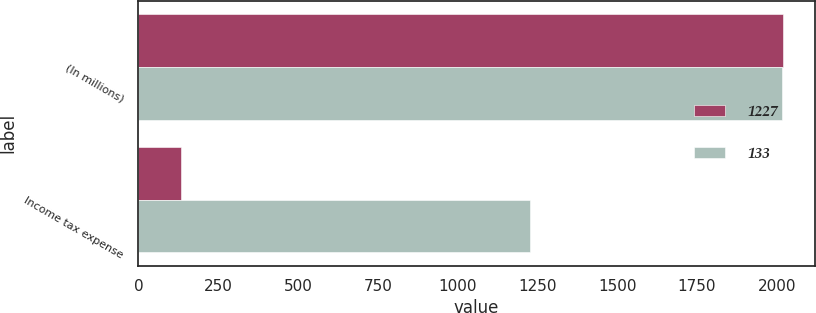Convert chart to OTSL. <chart><loc_0><loc_0><loc_500><loc_500><stacked_bar_chart><ecel><fcel>(In millions)<fcel>Income tax expense<nl><fcel>1227<fcel>2018<fcel>133<nl><fcel>133<fcel>2017<fcel>1227<nl></chart> 